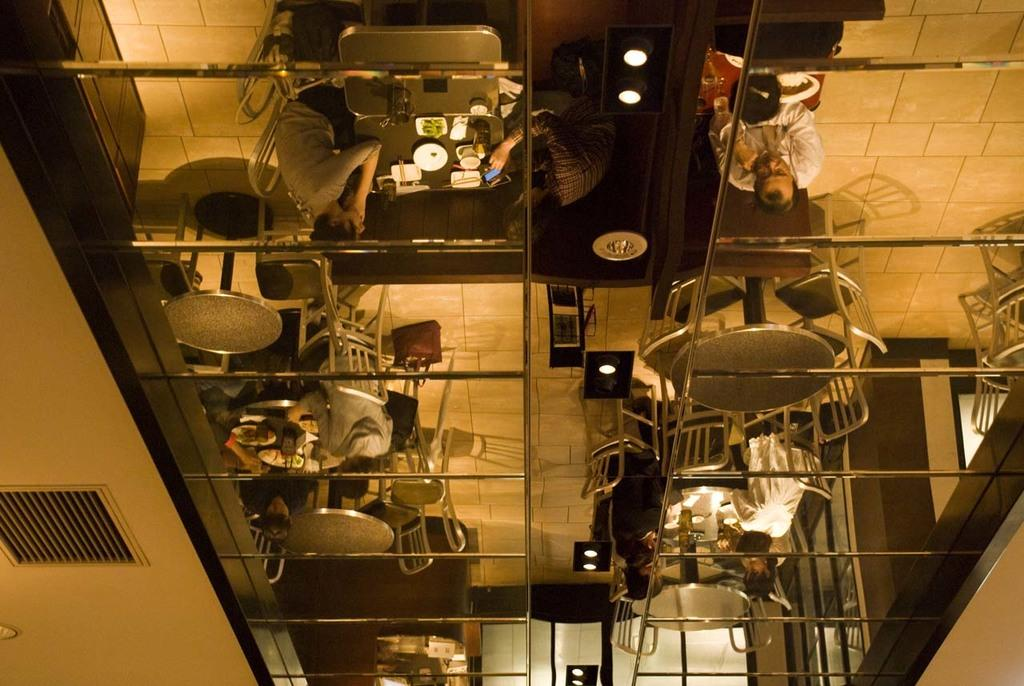What objects are present in the image that can reflect images? There are mirrors in the image. What can be seen in the mirrors' reflections? The mirrors reflect people, chairs, and tables. What is on top of the tables in the image? There are items on the tables. What part of the room can be seen in the image? The floor is visible in the image. What provides illumination in the image? There are lights in the image. What type of mine can be seen in the image? There is no mine present in the image. What does the lip of the person in the image look like? A: There are no visible lips of a person in the image. 